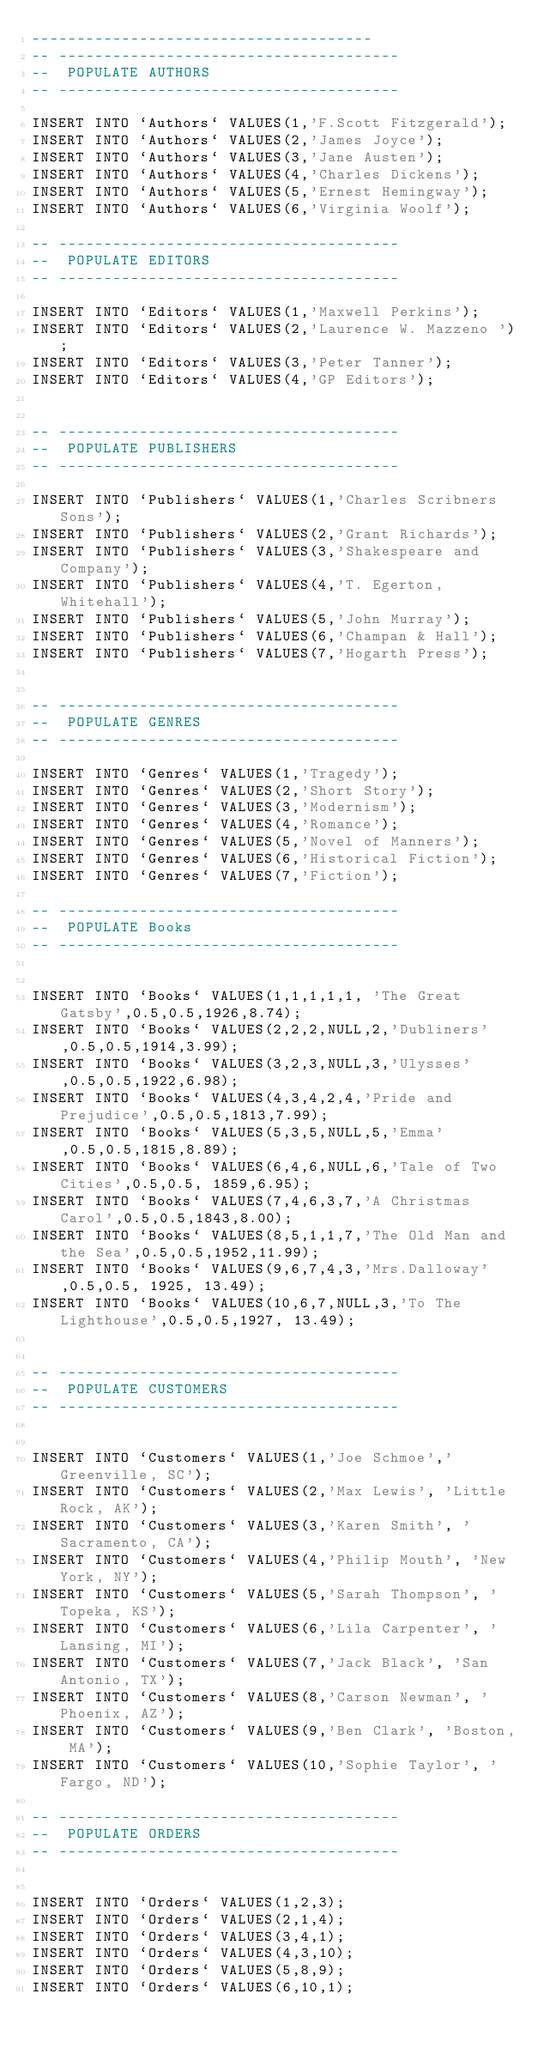<code> <loc_0><loc_0><loc_500><loc_500><_SQL_>--------------------------------------
-- --------------------------------------
--  POPULATE AUTHORS
-- --------------------------------------

INSERT INTO `Authors` VALUES(1,'F.Scott Fitzgerald');
INSERT INTO `Authors` VALUES(2,'James Joyce');
INSERT INTO `Authors` VALUES(3,'Jane Austen');
INSERT INTO `Authors` VALUES(4,'Charles Dickens');
INSERT INTO `Authors` VALUES(5,'Ernest Hemingway');
INSERT INTO `Authors` VALUES(6,'Virginia Woolf');

-- --------------------------------------
--  POPULATE EDITORS
-- --------------------------------------

INSERT INTO `Editors` VALUES(1,'Maxwell Perkins');
INSERT INTO `Editors` VALUES(2,'Laurence W. Mazzeno ');
INSERT INTO `Editors` VALUES(3,'Peter Tanner');
INSERT INTO `Editors` VALUES(4,'GP Editors');


-- --------------------------------------
--  POPULATE PUBLISHERS
-- --------------------------------------

INSERT INTO `Publishers` VALUES(1,'Charles Scribners Sons');
INSERT INTO `Publishers` VALUES(2,'Grant Richards');
INSERT INTO `Publishers` VALUES(3,'Shakespeare and Company');
INSERT INTO `Publishers` VALUES(4,'T. Egerton, Whitehall');
INSERT INTO `Publishers` VALUES(5,'John Murray');
INSERT INTO `Publishers` VALUES(6,'Champan & Hall');
INSERT INTO `Publishers` VALUES(7,'Hogarth Press');


-- --------------------------------------
--  POPULATE GENRES
-- --------------------------------------

INSERT INTO `Genres` VALUES(1,'Tragedy');
INSERT INTO `Genres` VALUES(2,'Short Story');
INSERT INTO `Genres` VALUES(3,'Modernism');
INSERT INTO `Genres` VALUES(4,'Romance');
INSERT INTO `Genres` VALUES(5,'Novel of Manners');
INSERT INTO `Genres` VALUES(6,'Historical Fiction');
INSERT INTO `Genres` VALUES(7,'Fiction');

-- --------------------------------------
--  POPULATE Books
-- --------------------------------------


INSERT INTO `Books` VALUES(1,1,1,1,1, 'The Great Gatsby',0.5,0.5,1926,8.74);
INSERT INTO `Books` VALUES(2,2,2,NULL,2,'Dubliners',0.5,0.5,1914,3.99);
INSERT INTO `Books` VALUES(3,2,3,NULL,3,'Ulysses',0.5,0.5,1922,6.98);
INSERT INTO `Books` VALUES(4,3,4,2,4,'Pride and Prejudice',0.5,0.5,1813,7.99);
INSERT INTO `Books` VALUES(5,3,5,NULL,5,'Emma',0.5,0.5,1815,8.89);
INSERT INTO `Books` VALUES(6,4,6,NULL,6,'Tale of Two Cities',0.5,0.5, 1859,6.95);
INSERT INTO `Books` VALUES(7,4,6,3,7,'A Christmas Carol',0.5,0.5,1843,8.00);
INSERT INTO `Books` VALUES(8,5,1,1,7,'The Old Man and the Sea',0.5,0.5,1952,11.99);
INSERT INTO `Books` VALUES(9,6,7,4,3,'Mrs.Dalloway',0.5,0.5, 1925, 13.49);
INSERT INTO `Books` VALUES(10,6,7,NULL,3,'To The Lighthouse',0.5,0.5,1927, 13.49);


-- --------------------------------------
--  POPULATE CUSTOMERS
-- --------------------------------------


INSERT INTO `Customers` VALUES(1,'Joe Schmoe','Greenville, SC');
INSERT INTO `Customers` VALUES(2,'Max Lewis', 'Little Rock, AK');
INSERT INTO `Customers` VALUES(3,'Karen Smith', 'Sacramento, CA');
INSERT INTO `Customers` VALUES(4,'Philip Mouth', 'New York, NY');
INSERT INTO `Customers` VALUES(5,'Sarah Thompson', 'Topeka, KS');
INSERT INTO `Customers` VALUES(6,'Lila Carpenter', 'Lansing, MI');
INSERT INTO `Customers` VALUES(7,'Jack Black', 'San Antonio, TX');
INSERT INTO `Customers` VALUES(8,'Carson Newman', 'Phoenix, AZ');
INSERT INTO `Customers` VALUES(9,'Ben Clark', 'Boston, MA');
INSERT INTO `Customers` VALUES(10,'Sophie Taylor', 'Fargo, ND');

-- --------------------------------------
--  POPULATE ORDERS
-- --------------------------------------


INSERT INTO `Orders` VALUES(1,2,3);
INSERT INTO `Orders` VALUES(2,1,4);
INSERT INTO `Orders` VALUES(3,4,1);
INSERT INTO `Orders` VALUES(4,3,10);
INSERT INTO `Orders` VALUES(5,8,9);
INSERT INTO `Orders` VALUES(6,10,1);</code> 